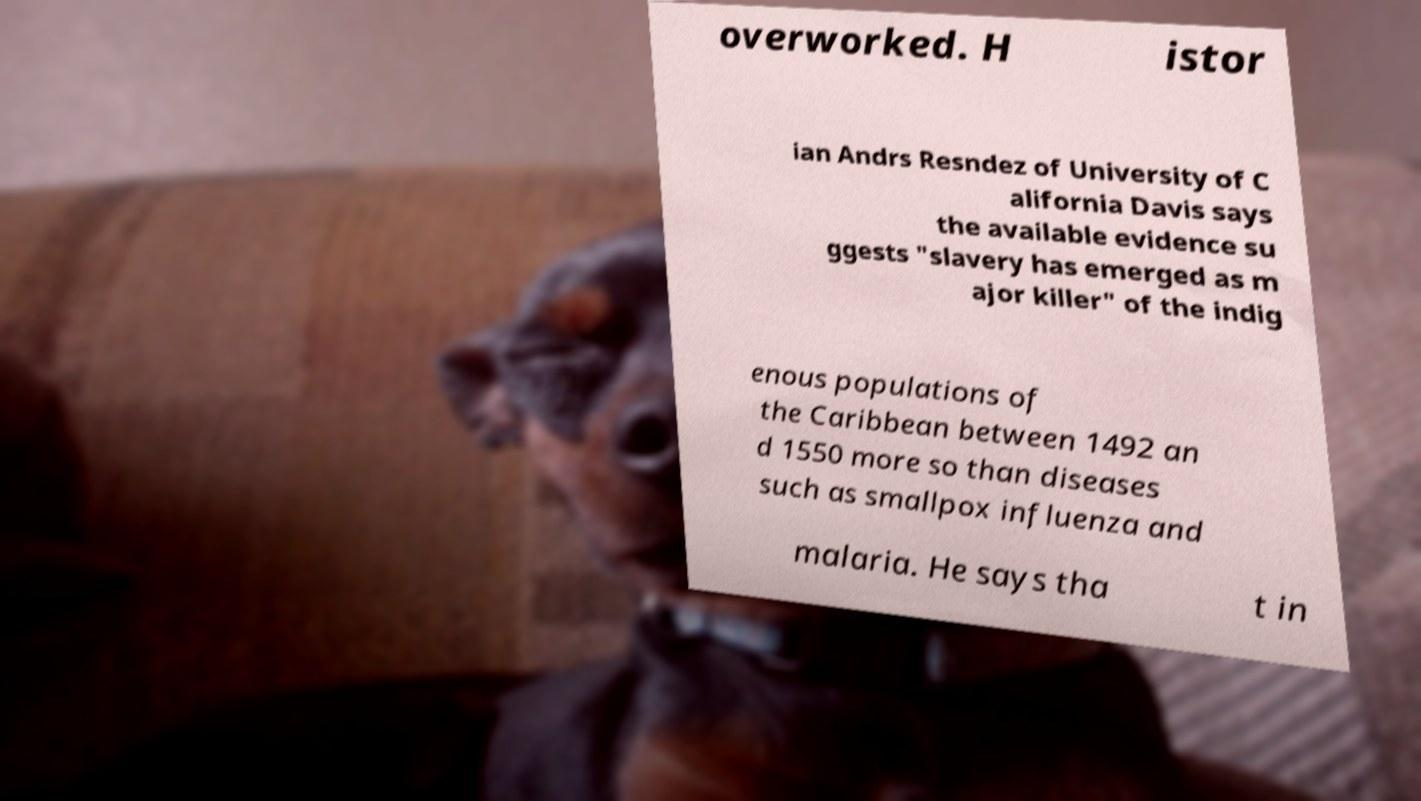Could you extract and type out the text from this image? overworked. H istor ian Andrs Resndez of University of C alifornia Davis says the available evidence su ggests "slavery has emerged as m ajor killer" of the indig enous populations of the Caribbean between 1492 an d 1550 more so than diseases such as smallpox influenza and malaria. He says tha t in 